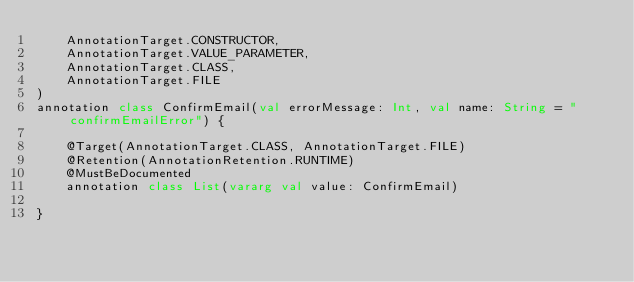Convert code to text. <code><loc_0><loc_0><loc_500><loc_500><_Kotlin_>    AnnotationTarget.CONSTRUCTOR,
    AnnotationTarget.VALUE_PARAMETER,
    AnnotationTarget.CLASS,
    AnnotationTarget.FILE
)
annotation class ConfirmEmail(val errorMessage: Int, val name: String = "confirmEmailError") {

    @Target(AnnotationTarget.CLASS, AnnotationTarget.FILE)
    @Retention(AnnotationRetention.RUNTIME)
    @MustBeDocumented
    annotation class List(vararg val value: ConfirmEmail)

}
</code> 